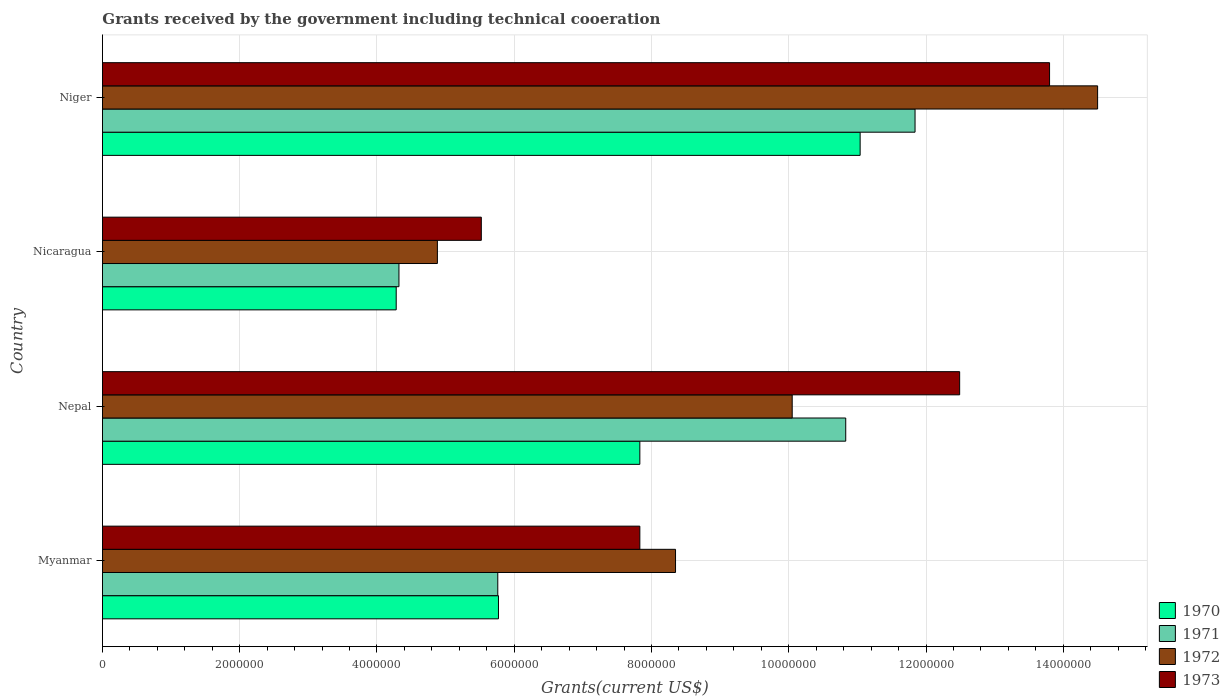Are the number of bars per tick equal to the number of legend labels?
Make the answer very short. Yes. Are the number of bars on each tick of the Y-axis equal?
Your response must be concise. Yes. How many bars are there on the 4th tick from the top?
Provide a short and direct response. 4. What is the label of the 1st group of bars from the top?
Offer a terse response. Niger. What is the total grants received by the government in 1972 in Myanmar?
Ensure brevity in your answer.  8.35e+06. Across all countries, what is the maximum total grants received by the government in 1972?
Your response must be concise. 1.45e+07. Across all countries, what is the minimum total grants received by the government in 1973?
Your response must be concise. 5.52e+06. In which country was the total grants received by the government in 1973 maximum?
Make the answer very short. Niger. In which country was the total grants received by the government in 1971 minimum?
Ensure brevity in your answer.  Nicaragua. What is the total total grants received by the government in 1973 in the graph?
Offer a terse response. 3.96e+07. What is the difference between the total grants received by the government in 1971 in Myanmar and that in Nicaragua?
Keep it short and to the point. 1.44e+06. What is the difference between the total grants received by the government in 1972 in Myanmar and the total grants received by the government in 1971 in Nicaragua?
Your answer should be very brief. 4.03e+06. What is the average total grants received by the government in 1971 per country?
Ensure brevity in your answer.  8.19e+06. What is the difference between the total grants received by the government in 1972 and total grants received by the government in 1973 in Nepal?
Offer a very short reply. -2.44e+06. In how many countries, is the total grants received by the government in 1970 greater than 400000 US$?
Make the answer very short. 4. Is the difference between the total grants received by the government in 1972 in Myanmar and Nicaragua greater than the difference between the total grants received by the government in 1973 in Myanmar and Nicaragua?
Ensure brevity in your answer.  Yes. What is the difference between the highest and the second highest total grants received by the government in 1972?
Your answer should be very brief. 4.45e+06. What is the difference between the highest and the lowest total grants received by the government in 1972?
Ensure brevity in your answer.  9.62e+06. In how many countries, is the total grants received by the government in 1973 greater than the average total grants received by the government in 1973 taken over all countries?
Your answer should be very brief. 2. Is the sum of the total grants received by the government in 1972 in Nicaragua and Niger greater than the maximum total grants received by the government in 1971 across all countries?
Your answer should be very brief. Yes. Is it the case that in every country, the sum of the total grants received by the government in 1973 and total grants received by the government in 1970 is greater than the sum of total grants received by the government in 1971 and total grants received by the government in 1972?
Offer a very short reply. No. What does the 2nd bar from the top in Niger represents?
Ensure brevity in your answer.  1972. What does the 3rd bar from the bottom in Nicaragua represents?
Keep it short and to the point. 1972. Is it the case that in every country, the sum of the total grants received by the government in 1973 and total grants received by the government in 1970 is greater than the total grants received by the government in 1972?
Offer a terse response. Yes. How many bars are there?
Your response must be concise. 16. Are all the bars in the graph horizontal?
Ensure brevity in your answer.  Yes. How many countries are there in the graph?
Offer a terse response. 4. What is the difference between two consecutive major ticks on the X-axis?
Ensure brevity in your answer.  2.00e+06. Are the values on the major ticks of X-axis written in scientific E-notation?
Give a very brief answer. No. Does the graph contain any zero values?
Make the answer very short. No. Does the graph contain grids?
Keep it short and to the point. Yes. How are the legend labels stacked?
Keep it short and to the point. Vertical. What is the title of the graph?
Your answer should be very brief. Grants received by the government including technical cooeration. Does "1984" appear as one of the legend labels in the graph?
Make the answer very short. No. What is the label or title of the X-axis?
Provide a short and direct response. Grants(current US$). What is the label or title of the Y-axis?
Offer a terse response. Country. What is the Grants(current US$) of 1970 in Myanmar?
Your answer should be very brief. 5.77e+06. What is the Grants(current US$) of 1971 in Myanmar?
Give a very brief answer. 5.76e+06. What is the Grants(current US$) in 1972 in Myanmar?
Make the answer very short. 8.35e+06. What is the Grants(current US$) of 1973 in Myanmar?
Ensure brevity in your answer.  7.83e+06. What is the Grants(current US$) in 1970 in Nepal?
Give a very brief answer. 7.83e+06. What is the Grants(current US$) of 1971 in Nepal?
Offer a terse response. 1.08e+07. What is the Grants(current US$) of 1972 in Nepal?
Provide a succinct answer. 1.00e+07. What is the Grants(current US$) of 1973 in Nepal?
Your answer should be very brief. 1.25e+07. What is the Grants(current US$) in 1970 in Nicaragua?
Your response must be concise. 4.28e+06. What is the Grants(current US$) of 1971 in Nicaragua?
Your answer should be very brief. 4.32e+06. What is the Grants(current US$) of 1972 in Nicaragua?
Your answer should be very brief. 4.88e+06. What is the Grants(current US$) in 1973 in Nicaragua?
Provide a succinct answer. 5.52e+06. What is the Grants(current US$) of 1970 in Niger?
Offer a terse response. 1.10e+07. What is the Grants(current US$) in 1971 in Niger?
Your response must be concise. 1.18e+07. What is the Grants(current US$) of 1972 in Niger?
Ensure brevity in your answer.  1.45e+07. What is the Grants(current US$) in 1973 in Niger?
Offer a very short reply. 1.38e+07. Across all countries, what is the maximum Grants(current US$) of 1970?
Give a very brief answer. 1.10e+07. Across all countries, what is the maximum Grants(current US$) of 1971?
Your answer should be compact. 1.18e+07. Across all countries, what is the maximum Grants(current US$) in 1972?
Your answer should be very brief. 1.45e+07. Across all countries, what is the maximum Grants(current US$) in 1973?
Offer a terse response. 1.38e+07. Across all countries, what is the minimum Grants(current US$) of 1970?
Provide a succinct answer. 4.28e+06. Across all countries, what is the minimum Grants(current US$) in 1971?
Your response must be concise. 4.32e+06. Across all countries, what is the minimum Grants(current US$) of 1972?
Make the answer very short. 4.88e+06. Across all countries, what is the minimum Grants(current US$) of 1973?
Provide a succinct answer. 5.52e+06. What is the total Grants(current US$) in 1970 in the graph?
Make the answer very short. 2.89e+07. What is the total Grants(current US$) in 1971 in the graph?
Ensure brevity in your answer.  3.28e+07. What is the total Grants(current US$) in 1972 in the graph?
Ensure brevity in your answer.  3.78e+07. What is the total Grants(current US$) of 1973 in the graph?
Provide a succinct answer. 3.96e+07. What is the difference between the Grants(current US$) in 1970 in Myanmar and that in Nepal?
Keep it short and to the point. -2.06e+06. What is the difference between the Grants(current US$) in 1971 in Myanmar and that in Nepal?
Offer a terse response. -5.07e+06. What is the difference between the Grants(current US$) in 1972 in Myanmar and that in Nepal?
Your answer should be compact. -1.70e+06. What is the difference between the Grants(current US$) of 1973 in Myanmar and that in Nepal?
Ensure brevity in your answer.  -4.66e+06. What is the difference between the Grants(current US$) in 1970 in Myanmar and that in Nicaragua?
Your response must be concise. 1.49e+06. What is the difference between the Grants(current US$) of 1971 in Myanmar and that in Nicaragua?
Your answer should be very brief. 1.44e+06. What is the difference between the Grants(current US$) in 1972 in Myanmar and that in Nicaragua?
Offer a terse response. 3.47e+06. What is the difference between the Grants(current US$) of 1973 in Myanmar and that in Nicaragua?
Offer a very short reply. 2.31e+06. What is the difference between the Grants(current US$) in 1970 in Myanmar and that in Niger?
Your response must be concise. -5.27e+06. What is the difference between the Grants(current US$) of 1971 in Myanmar and that in Niger?
Your answer should be very brief. -6.08e+06. What is the difference between the Grants(current US$) of 1972 in Myanmar and that in Niger?
Your answer should be very brief. -6.15e+06. What is the difference between the Grants(current US$) in 1973 in Myanmar and that in Niger?
Ensure brevity in your answer.  -5.97e+06. What is the difference between the Grants(current US$) in 1970 in Nepal and that in Nicaragua?
Your response must be concise. 3.55e+06. What is the difference between the Grants(current US$) in 1971 in Nepal and that in Nicaragua?
Provide a succinct answer. 6.51e+06. What is the difference between the Grants(current US$) of 1972 in Nepal and that in Nicaragua?
Keep it short and to the point. 5.17e+06. What is the difference between the Grants(current US$) in 1973 in Nepal and that in Nicaragua?
Make the answer very short. 6.97e+06. What is the difference between the Grants(current US$) in 1970 in Nepal and that in Niger?
Your answer should be very brief. -3.21e+06. What is the difference between the Grants(current US$) in 1971 in Nepal and that in Niger?
Your answer should be compact. -1.01e+06. What is the difference between the Grants(current US$) of 1972 in Nepal and that in Niger?
Offer a very short reply. -4.45e+06. What is the difference between the Grants(current US$) in 1973 in Nepal and that in Niger?
Ensure brevity in your answer.  -1.31e+06. What is the difference between the Grants(current US$) in 1970 in Nicaragua and that in Niger?
Offer a very short reply. -6.76e+06. What is the difference between the Grants(current US$) of 1971 in Nicaragua and that in Niger?
Keep it short and to the point. -7.52e+06. What is the difference between the Grants(current US$) in 1972 in Nicaragua and that in Niger?
Provide a succinct answer. -9.62e+06. What is the difference between the Grants(current US$) in 1973 in Nicaragua and that in Niger?
Make the answer very short. -8.28e+06. What is the difference between the Grants(current US$) in 1970 in Myanmar and the Grants(current US$) in 1971 in Nepal?
Your answer should be very brief. -5.06e+06. What is the difference between the Grants(current US$) of 1970 in Myanmar and the Grants(current US$) of 1972 in Nepal?
Offer a terse response. -4.28e+06. What is the difference between the Grants(current US$) of 1970 in Myanmar and the Grants(current US$) of 1973 in Nepal?
Offer a terse response. -6.72e+06. What is the difference between the Grants(current US$) of 1971 in Myanmar and the Grants(current US$) of 1972 in Nepal?
Ensure brevity in your answer.  -4.29e+06. What is the difference between the Grants(current US$) of 1971 in Myanmar and the Grants(current US$) of 1973 in Nepal?
Keep it short and to the point. -6.73e+06. What is the difference between the Grants(current US$) in 1972 in Myanmar and the Grants(current US$) in 1973 in Nepal?
Ensure brevity in your answer.  -4.14e+06. What is the difference between the Grants(current US$) in 1970 in Myanmar and the Grants(current US$) in 1971 in Nicaragua?
Give a very brief answer. 1.45e+06. What is the difference between the Grants(current US$) in 1970 in Myanmar and the Grants(current US$) in 1972 in Nicaragua?
Ensure brevity in your answer.  8.90e+05. What is the difference between the Grants(current US$) in 1971 in Myanmar and the Grants(current US$) in 1972 in Nicaragua?
Offer a very short reply. 8.80e+05. What is the difference between the Grants(current US$) of 1971 in Myanmar and the Grants(current US$) of 1973 in Nicaragua?
Provide a short and direct response. 2.40e+05. What is the difference between the Grants(current US$) of 1972 in Myanmar and the Grants(current US$) of 1973 in Nicaragua?
Offer a very short reply. 2.83e+06. What is the difference between the Grants(current US$) of 1970 in Myanmar and the Grants(current US$) of 1971 in Niger?
Keep it short and to the point. -6.07e+06. What is the difference between the Grants(current US$) in 1970 in Myanmar and the Grants(current US$) in 1972 in Niger?
Ensure brevity in your answer.  -8.73e+06. What is the difference between the Grants(current US$) in 1970 in Myanmar and the Grants(current US$) in 1973 in Niger?
Your answer should be compact. -8.03e+06. What is the difference between the Grants(current US$) in 1971 in Myanmar and the Grants(current US$) in 1972 in Niger?
Provide a succinct answer. -8.74e+06. What is the difference between the Grants(current US$) in 1971 in Myanmar and the Grants(current US$) in 1973 in Niger?
Your response must be concise. -8.04e+06. What is the difference between the Grants(current US$) in 1972 in Myanmar and the Grants(current US$) in 1973 in Niger?
Offer a terse response. -5.45e+06. What is the difference between the Grants(current US$) in 1970 in Nepal and the Grants(current US$) in 1971 in Nicaragua?
Give a very brief answer. 3.51e+06. What is the difference between the Grants(current US$) in 1970 in Nepal and the Grants(current US$) in 1972 in Nicaragua?
Provide a succinct answer. 2.95e+06. What is the difference between the Grants(current US$) in 1970 in Nepal and the Grants(current US$) in 1973 in Nicaragua?
Your answer should be very brief. 2.31e+06. What is the difference between the Grants(current US$) in 1971 in Nepal and the Grants(current US$) in 1972 in Nicaragua?
Provide a succinct answer. 5.95e+06. What is the difference between the Grants(current US$) of 1971 in Nepal and the Grants(current US$) of 1973 in Nicaragua?
Your response must be concise. 5.31e+06. What is the difference between the Grants(current US$) of 1972 in Nepal and the Grants(current US$) of 1973 in Nicaragua?
Give a very brief answer. 4.53e+06. What is the difference between the Grants(current US$) of 1970 in Nepal and the Grants(current US$) of 1971 in Niger?
Your response must be concise. -4.01e+06. What is the difference between the Grants(current US$) in 1970 in Nepal and the Grants(current US$) in 1972 in Niger?
Your response must be concise. -6.67e+06. What is the difference between the Grants(current US$) in 1970 in Nepal and the Grants(current US$) in 1973 in Niger?
Provide a succinct answer. -5.97e+06. What is the difference between the Grants(current US$) of 1971 in Nepal and the Grants(current US$) of 1972 in Niger?
Your answer should be compact. -3.67e+06. What is the difference between the Grants(current US$) of 1971 in Nepal and the Grants(current US$) of 1973 in Niger?
Your response must be concise. -2.97e+06. What is the difference between the Grants(current US$) of 1972 in Nepal and the Grants(current US$) of 1973 in Niger?
Provide a short and direct response. -3.75e+06. What is the difference between the Grants(current US$) in 1970 in Nicaragua and the Grants(current US$) in 1971 in Niger?
Ensure brevity in your answer.  -7.56e+06. What is the difference between the Grants(current US$) in 1970 in Nicaragua and the Grants(current US$) in 1972 in Niger?
Your answer should be compact. -1.02e+07. What is the difference between the Grants(current US$) in 1970 in Nicaragua and the Grants(current US$) in 1973 in Niger?
Provide a succinct answer. -9.52e+06. What is the difference between the Grants(current US$) in 1971 in Nicaragua and the Grants(current US$) in 1972 in Niger?
Ensure brevity in your answer.  -1.02e+07. What is the difference between the Grants(current US$) in 1971 in Nicaragua and the Grants(current US$) in 1973 in Niger?
Your answer should be compact. -9.48e+06. What is the difference between the Grants(current US$) in 1972 in Nicaragua and the Grants(current US$) in 1973 in Niger?
Give a very brief answer. -8.92e+06. What is the average Grants(current US$) in 1970 per country?
Give a very brief answer. 7.23e+06. What is the average Grants(current US$) in 1971 per country?
Keep it short and to the point. 8.19e+06. What is the average Grants(current US$) of 1972 per country?
Ensure brevity in your answer.  9.44e+06. What is the average Grants(current US$) in 1973 per country?
Give a very brief answer. 9.91e+06. What is the difference between the Grants(current US$) of 1970 and Grants(current US$) of 1971 in Myanmar?
Provide a short and direct response. 10000. What is the difference between the Grants(current US$) in 1970 and Grants(current US$) in 1972 in Myanmar?
Provide a short and direct response. -2.58e+06. What is the difference between the Grants(current US$) in 1970 and Grants(current US$) in 1973 in Myanmar?
Your answer should be compact. -2.06e+06. What is the difference between the Grants(current US$) in 1971 and Grants(current US$) in 1972 in Myanmar?
Keep it short and to the point. -2.59e+06. What is the difference between the Grants(current US$) of 1971 and Grants(current US$) of 1973 in Myanmar?
Your answer should be very brief. -2.07e+06. What is the difference between the Grants(current US$) of 1972 and Grants(current US$) of 1973 in Myanmar?
Your answer should be compact. 5.20e+05. What is the difference between the Grants(current US$) of 1970 and Grants(current US$) of 1971 in Nepal?
Give a very brief answer. -3.00e+06. What is the difference between the Grants(current US$) of 1970 and Grants(current US$) of 1972 in Nepal?
Offer a very short reply. -2.22e+06. What is the difference between the Grants(current US$) of 1970 and Grants(current US$) of 1973 in Nepal?
Offer a terse response. -4.66e+06. What is the difference between the Grants(current US$) in 1971 and Grants(current US$) in 1972 in Nepal?
Keep it short and to the point. 7.80e+05. What is the difference between the Grants(current US$) in 1971 and Grants(current US$) in 1973 in Nepal?
Make the answer very short. -1.66e+06. What is the difference between the Grants(current US$) of 1972 and Grants(current US$) of 1973 in Nepal?
Provide a short and direct response. -2.44e+06. What is the difference between the Grants(current US$) of 1970 and Grants(current US$) of 1972 in Nicaragua?
Give a very brief answer. -6.00e+05. What is the difference between the Grants(current US$) of 1970 and Grants(current US$) of 1973 in Nicaragua?
Your answer should be very brief. -1.24e+06. What is the difference between the Grants(current US$) in 1971 and Grants(current US$) in 1972 in Nicaragua?
Provide a short and direct response. -5.60e+05. What is the difference between the Grants(current US$) in 1971 and Grants(current US$) in 1973 in Nicaragua?
Your response must be concise. -1.20e+06. What is the difference between the Grants(current US$) of 1972 and Grants(current US$) of 1973 in Nicaragua?
Offer a very short reply. -6.40e+05. What is the difference between the Grants(current US$) in 1970 and Grants(current US$) in 1971 in Niger?
Offer a terse response. -8.00e+05. What is the difference between the Grants(current US$) in 1970 and Grants(current US$) in 1972 in Niger?
Ensure brevity in your answer.  -3.46e+06. What is the difference between the Grants(current US$) of 1970 and Grants(current US$) of 1973 in Niger?
Your answer should be very brief. -2.76e+06. What is the difference between the Grants(current US$) in 1971 and Grants(current US$) in 1972 in Niger?
Keep it short and to the point. -2.66e+06. What is the difference between the Grants(current US$) in 1971 and Grants(current US$) in 1973 in Niger?
Offer a very short reply. -1.96e+06. What is the ratio of the Grants(current US$) in 1970 in Myanmar to that in Nepal?
Offer a terse response. 0.74. What is the ratio of the Grants(current US$) of 1971 in Myanmar to that in Nepal?
Provide a succinct answer. 0.53. What is the ratio of the Grants(current US$) of 1972 in Myanmar to that in Nepal?
Ensure brevity in your answer.  0.83. What is the ratio of the Grants(current US$) of 1973 in Myanmar to that in Nepal?
Make the answer very short. 0.63. What is the ratio of the Grants(current US$) in 1970 in Myanmar to that in Nicaragua?
Provide a short and direct response. 1.35. What is the ratio of the Grants(current US$) of 1972 in Myanmar to that in Nicaragua?
Provide a short and direct response. 1.71. What is the ratio of the Grants(current US$) in 1973 in Myanmar to that in Nicaragua?
Offer a terse response. 1.42. What is the ratio of the Grants(current US$) in 1970 in Myanmar to that in Niger?
Ensure brevity in your answer.  0.52. What is the ratio of the Grants(current US$) in 1971 in Myanmar to that in Niger?
Offer a very short reply. 0.49. What is the ratio of the Grants(current US$) of 1972 in Myanmar to that in Niger?
Give a very brief answer. 0.58. What is the ratio of the Grants(current US$) in 1973 in Myanmar to that in Niger?
Your answer should be very brief. 0.57. What is the ratio of the Grants(current US$) of 1970 in Nepal to that in Nicaragua?
Your answer should be compact. 1.83. What is the ratio of the Grants(current US$) of 1971 in Nepal to that in Nicaragua?
Provide a short and direct response. 2.51. What is the ratio of the Grants(current US$) of 1972 in Nepal to that in Nicaragua?
Make the answer very short. 2.06. What is the ratio of the Grants(current US$) in 1973 in Nepal to that in Nicaragua?
Your response must be concise. 2.26. What is the ratio of the Grants(current US$) in 1970 in Nepal to that in Niger?
Keep it short and to the point. 0.71. What is the ratio of the Grants(current US$) of 1971 in Nepal to that in Niger?
Provide a short and direct response. 0.91. What is the ratio of the Grants(current US$) of 1972 in Nepal to that in Niger?
Your answer should be compact. 0.69. What is the ratio of the Grants(current US$) of 1973 in Nepal to that in Niger?
Your response must be concise. 0.91. What is the ratio of the Grants(current US$) in 1970 in Nicaragua to that in Niger?
Your answer should be very brief. 0.39. What is the ratio of the Grants(current US$) in 1971 in Nicaragua to that in Niger?
Provide a succinct answer. 0.36. What is the ratio of the Grants(current US$) in 1972 in Nicaragua to that in Niger?
Provide a succinct answer. 0.34. What is the difference between the highest and the second highest Grants(current US$) of 1970?
Your answer should be very brief. 3.21e+06. What is the difference between the highest and the second highest Grants(current US$) in 1971?
Offer a terse response. 1.01e+06. What is the difference between the highest and the second highest Grants(current US$) of 1972?
Make the answer very short. 4.45e+06. What is the difference between the highest and the second highest Grants(current US$) of 1973?
Provide a succinct answer. 1.31e+06. What is the difference between the highest and the lowest Grants(current US$) in 1970?
Your answer should be compact. 6.76e+06. What is the difference between the highest and the lowest Grants(current US$) of 1971?
Make the answer very short. 7.52e+06. What is the difference between the highest and the lowest Grants(current US$) in 1972?
Provide a short and direct response. 9.62e+06. What is the difference between the highest and the lowest Grants(current US$) in 1973?
Make the answer very short. 8.28e+06. 